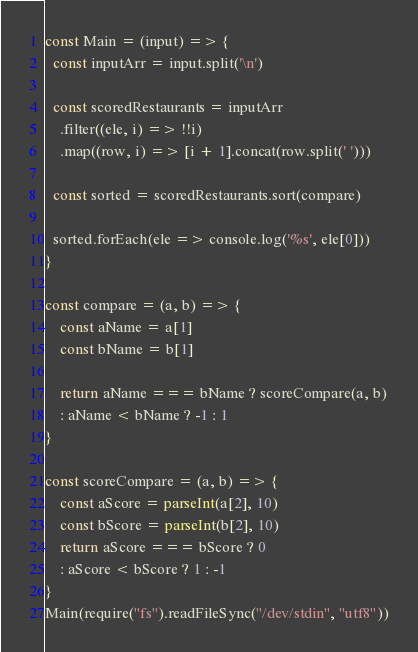<code> <loc_0><loc_0><loc_500><loc_500><_JavaScript_>const Main = (input) => {
  const inputArr = input.split('\n')

  const scoredRestaurants = inputArr
    .filter((ele, i) => !!i)
    .map((row, i) => [i + 1].concat(row.split(' ')))

  const sorted = scoredRestaurants.sort(compare)

  sorted.forEach(ele => console.log('%s', ele[0]))
}

const compare = (a, b) => {
    const aName = a[1]
    const bName = b[1]

    return aName === bName ? scoreCompare(a, b)
    : aName < bName ? -1 : 1
}

const scoreCompare = (a, b) => {
    const aScore = parseInt(a[2], 10)
    const bScore = parseInt(b[2], 10)
    return aScore === bScore ? 0
    : aScore < bScore ? 1 : -1
}
Main(require("fs").readFileSync("/dev/stdin", "utf8"))</code> 